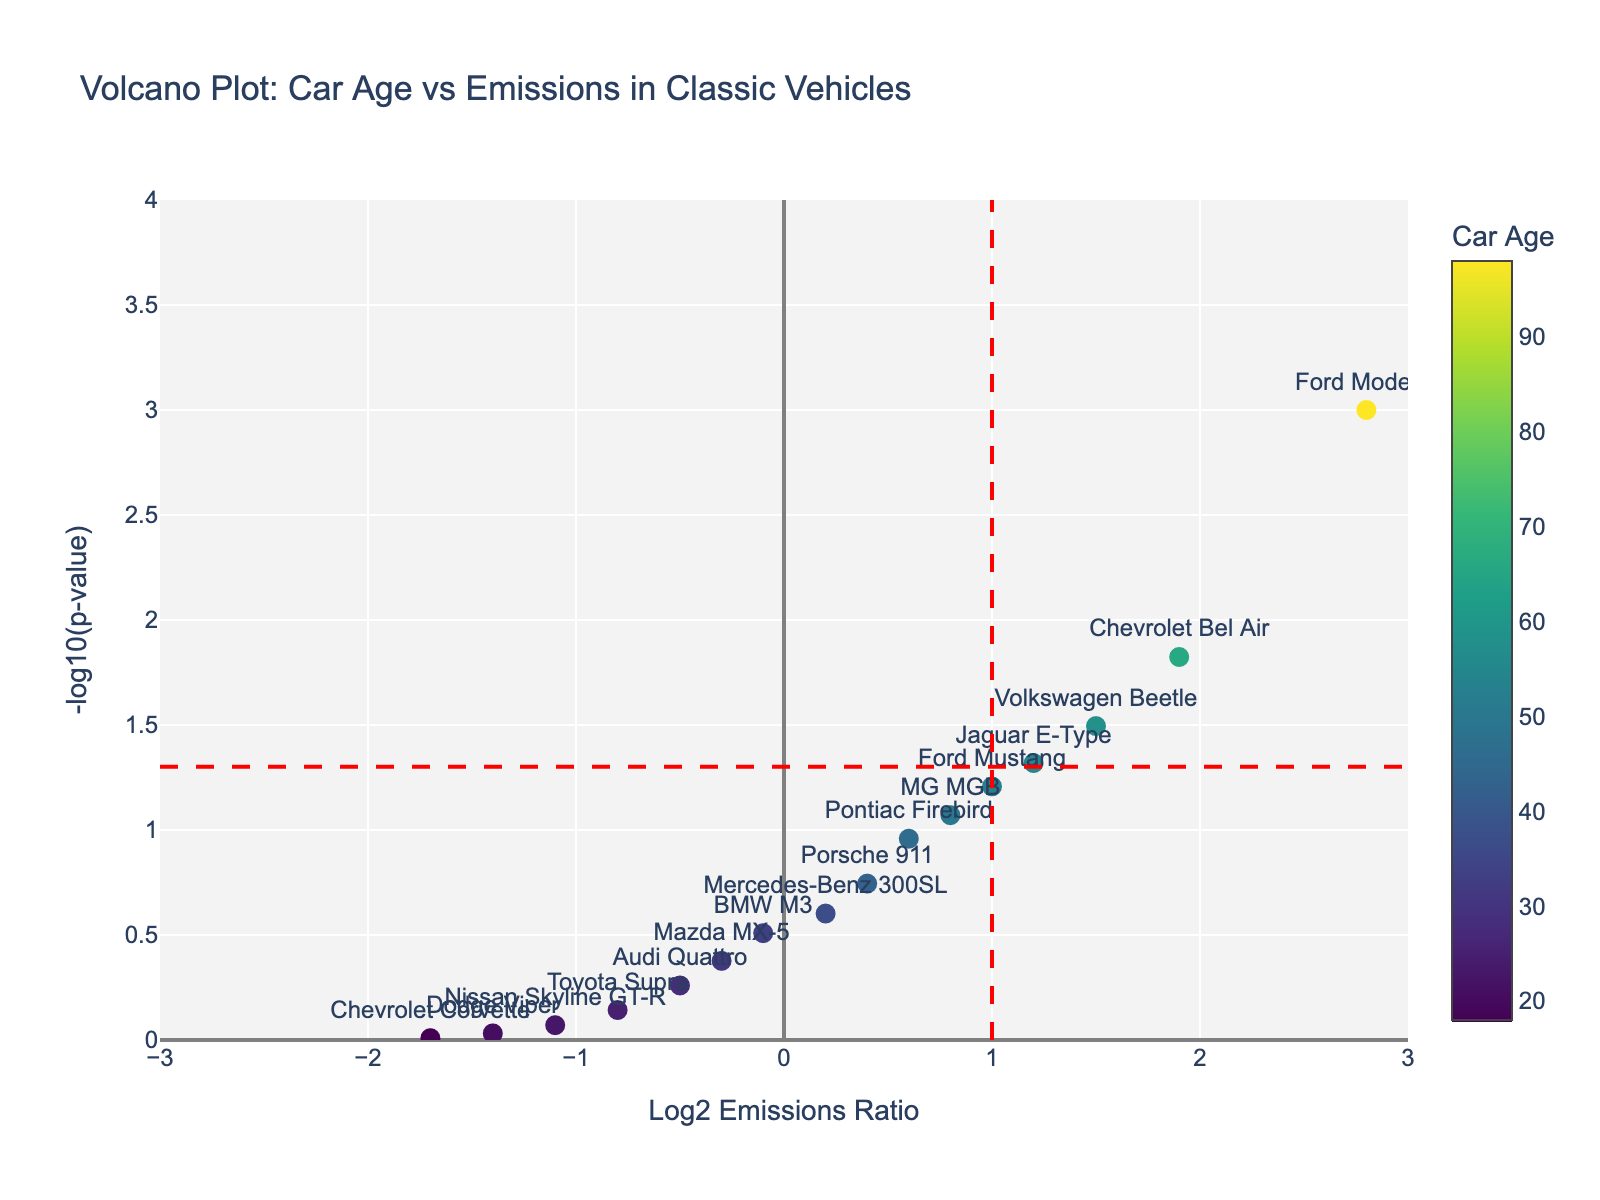How many cars are plotted in the figure? By counting the number of data points in the figure, we can see that each car model corresponds to one point. Counting these points gives the total number of cars plotted.
Answer: 15 What does the color bar on the right represent? The color bar on the right of the plot indicates the age of the cars. Darker colors represent older cars, and lighter colors represent newer cars.
Answer: Car age What is the title of the plot? The title of the plot is displayed at the top of the figure. It gives an overview of the content and context of the plot.
Answer: Volcano Plot: Car Age vs Emissions in Classic Vehicles Which car has the highest Log2 Emissions Ratio, and what is its value? By looking at the x-axis and identifying the data point furthest to the right, the Ford Model T has the highest Log2 Emissions Ratio. The value associated with this point is 2.8.
Answer: Ford Model T, 2.8 Compare the emissions of the Ford Mustang and the Chevrolet Corvette. Which has a higher Log2 Emissions Ratio? By locating the data points for the Ford Mustang and the Chevrolet Corvette on the plot, we observe their positions on the x-axis. The Ford Mustang has a higher Log2 Emissions Ratio with a value of 1.0 compared to the Chevrolet Corvette's -1.7.
Answer: Ford Mustang Which car is the oldest and what is its age? The color mapping corresponds to the car's age, with darker colors representing older cars. The Ford Model T, with the darkest color, is the oldest. The plot text or legend confirms the age is 98 years.
Answer: Ford Model T, 98 What is the threshold p-value for statistical significance? The threshold p-value for statistical significance is derived from the horizontal red dashed line in the plot, which denotes -log10(p-value) = 1.3. Rewriting this, we get p-value = 10^-1.3.
Answer: 0.05 What is the relationship between car age and emission levels as indicated by the color gradient of the plot? Observing the colors, older cars (darker colors) generally show higher positive Log2 Emissions Ratios, while newer cars (lighter colors) tend to have lower or negative ratios. This suggests older cars have higher emissions.
Answer: Older cars have higher emissions Which cars fall into the statistically significant high emissions category? Statistically significant points have both a Log2 Emissions Ratio > 1 and p-value < 0.05. The cars falling in this category appear to the right of the vertical line and above the horizontal line. They are the Ford Model T, Chevrolet Bel Air, and Volkswagen Beetle.
Answer: Ford Model T, Chevrolet Bel Air, Volkswagen Beetle How many cars have a negative Log2 Emissions Ratio, and what does it indicate about their emissions? Counting data points to the left of zero on the x-axis indicates cars with a negative Log2 Emissions Ratio. There are six such cars, indicating their emissions are lower compared to a reference.
Answer: 6, lower emissions 